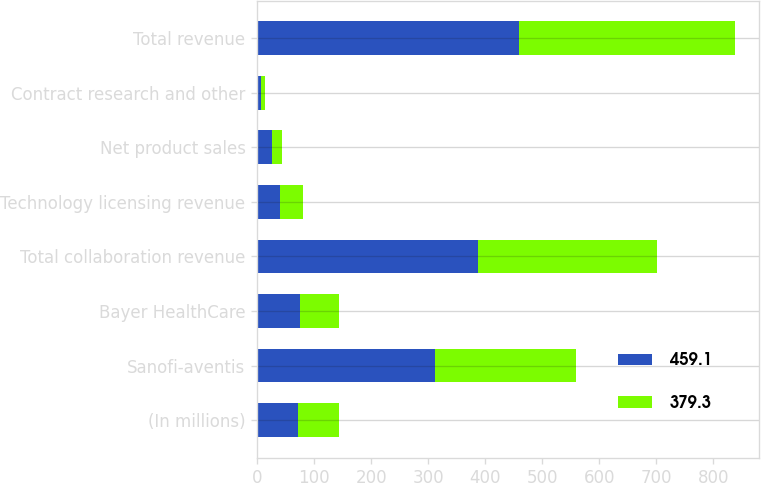Convert chart. <chart><loc_0><loc_0><loc_500><loc_500><stacked_bar_chart><ecel><fcel>(In millions)<fcel>Sanofi-aventis<fcel>Bayer HealthCare<fcel>Total collaboration revenue<fcel>Technology licensing revenue<fcel>Net product sales<fcel>Contract research and other<fcel>Total revenue<nl><fcel>459.1<fcel>71.35<fcel>311.3<fcel>75.4<fcel>386.7<fcel>40.2<fcel>25.3<fcel>6.9<fcel>459.1<nl><fcel>379.3<fcel>71.35<fcel>247.2<fcel>67.3<fcel>314.5<fcel>40<fcel>18.4<fcel>6.4<fcel>379.3<nl></chart> 